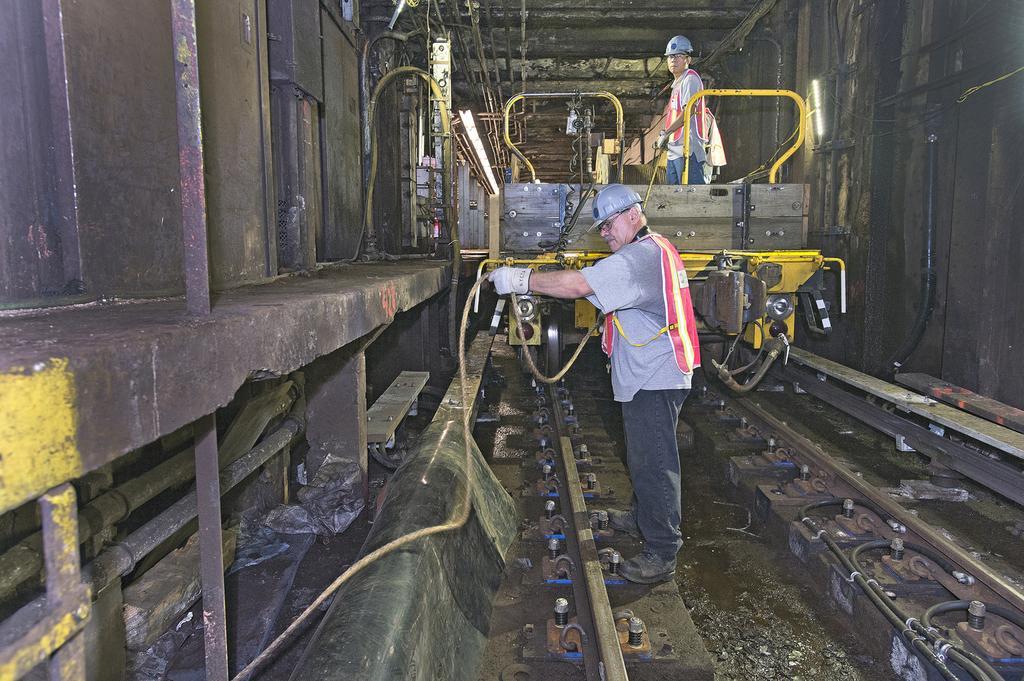Can you describe this image briefly? In this picture we can see a person holding a pipe in his hand. There is a man standing on a vehicle. We can see a railway track on the path. 